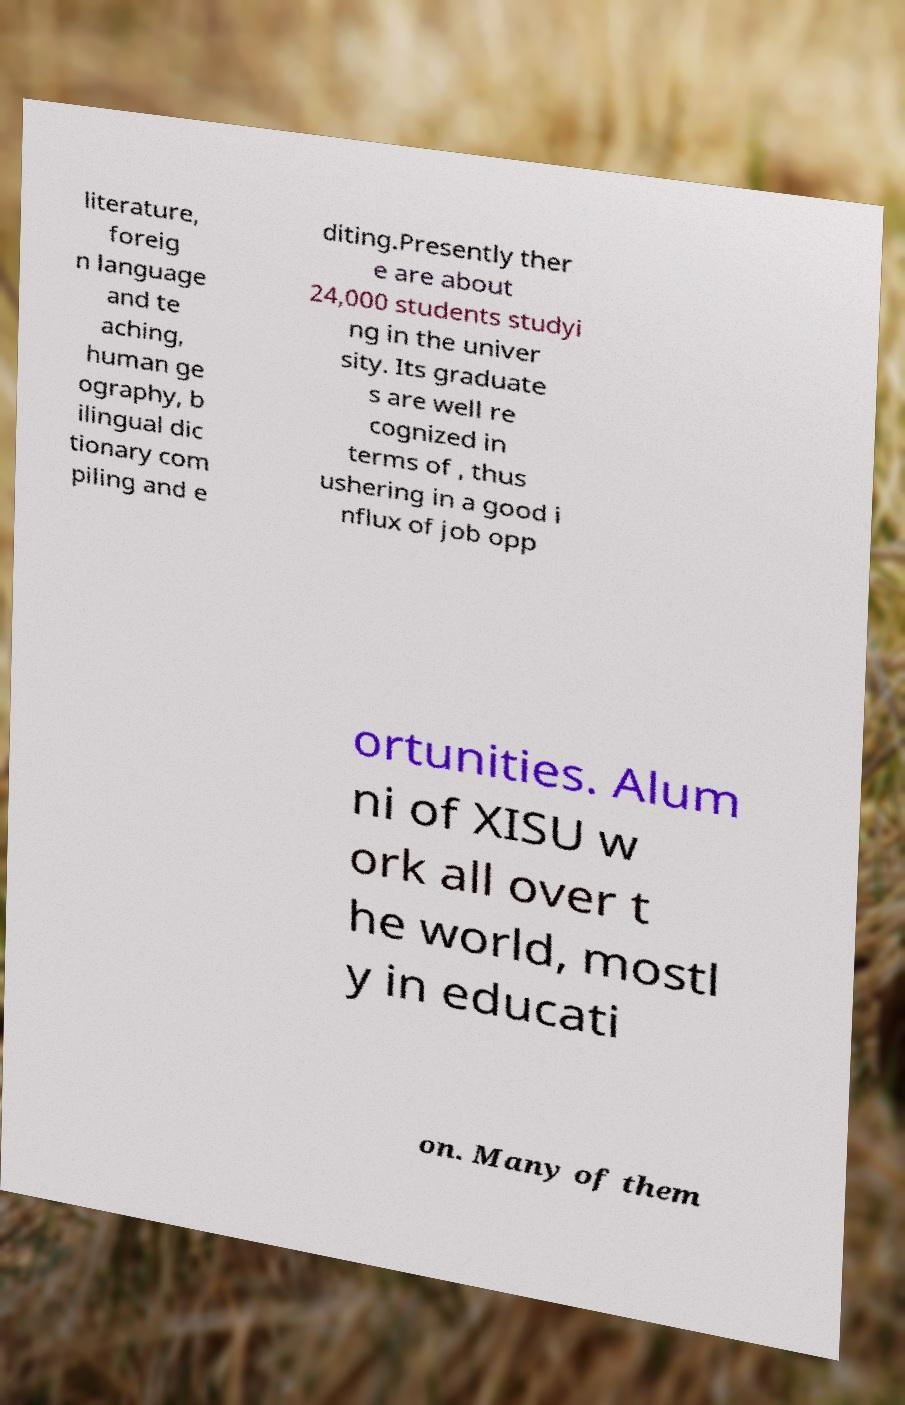There's text embedded in this image that I need extracted. Can you transcribe it verbatim? literature, foreig n language and te aching, human ge ography, b ilingual dic tionary com piling and e diting.Presently ther e are about 24,000 students studyi ng in the univer sity. Its graduate s are well re cognized in terms of , thus ushering in a good i nflux of job opp ortunities. Alum ni of XISU w ork all over t he world, mostl y in educati on. Many of them 